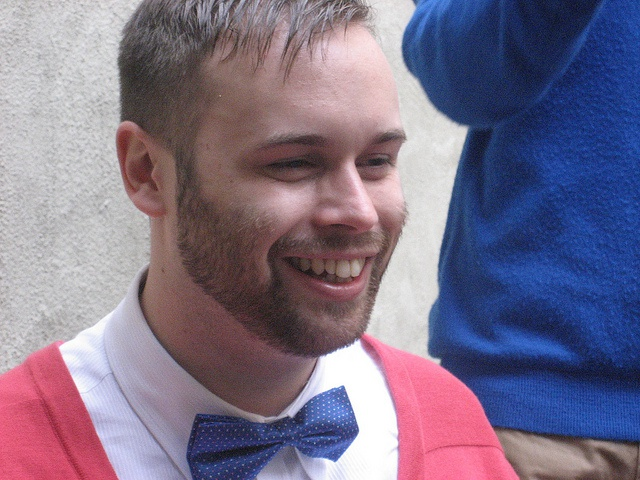Describe the objects in this image and their specific colors. I can see people in darkgray, gray, and lavender tones, people in darkgray, navy, blue, and darkblue tones, and tie in darkgray, navy, blue, black, and darkblue tones in this image. 